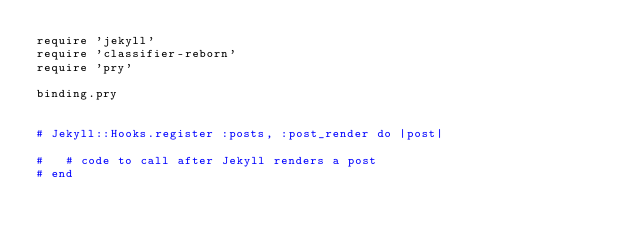<code> <loc_0><loc_0><loc_500><loc_500><_Ruby_>require 'jekyll'
require 'classifier-reborn'
require 'pry'

binding.pry


# Jekyll::Hooks.register :posts, :post_render do |post|

#   # code to call after Jekyll renders a post
# end</code> 